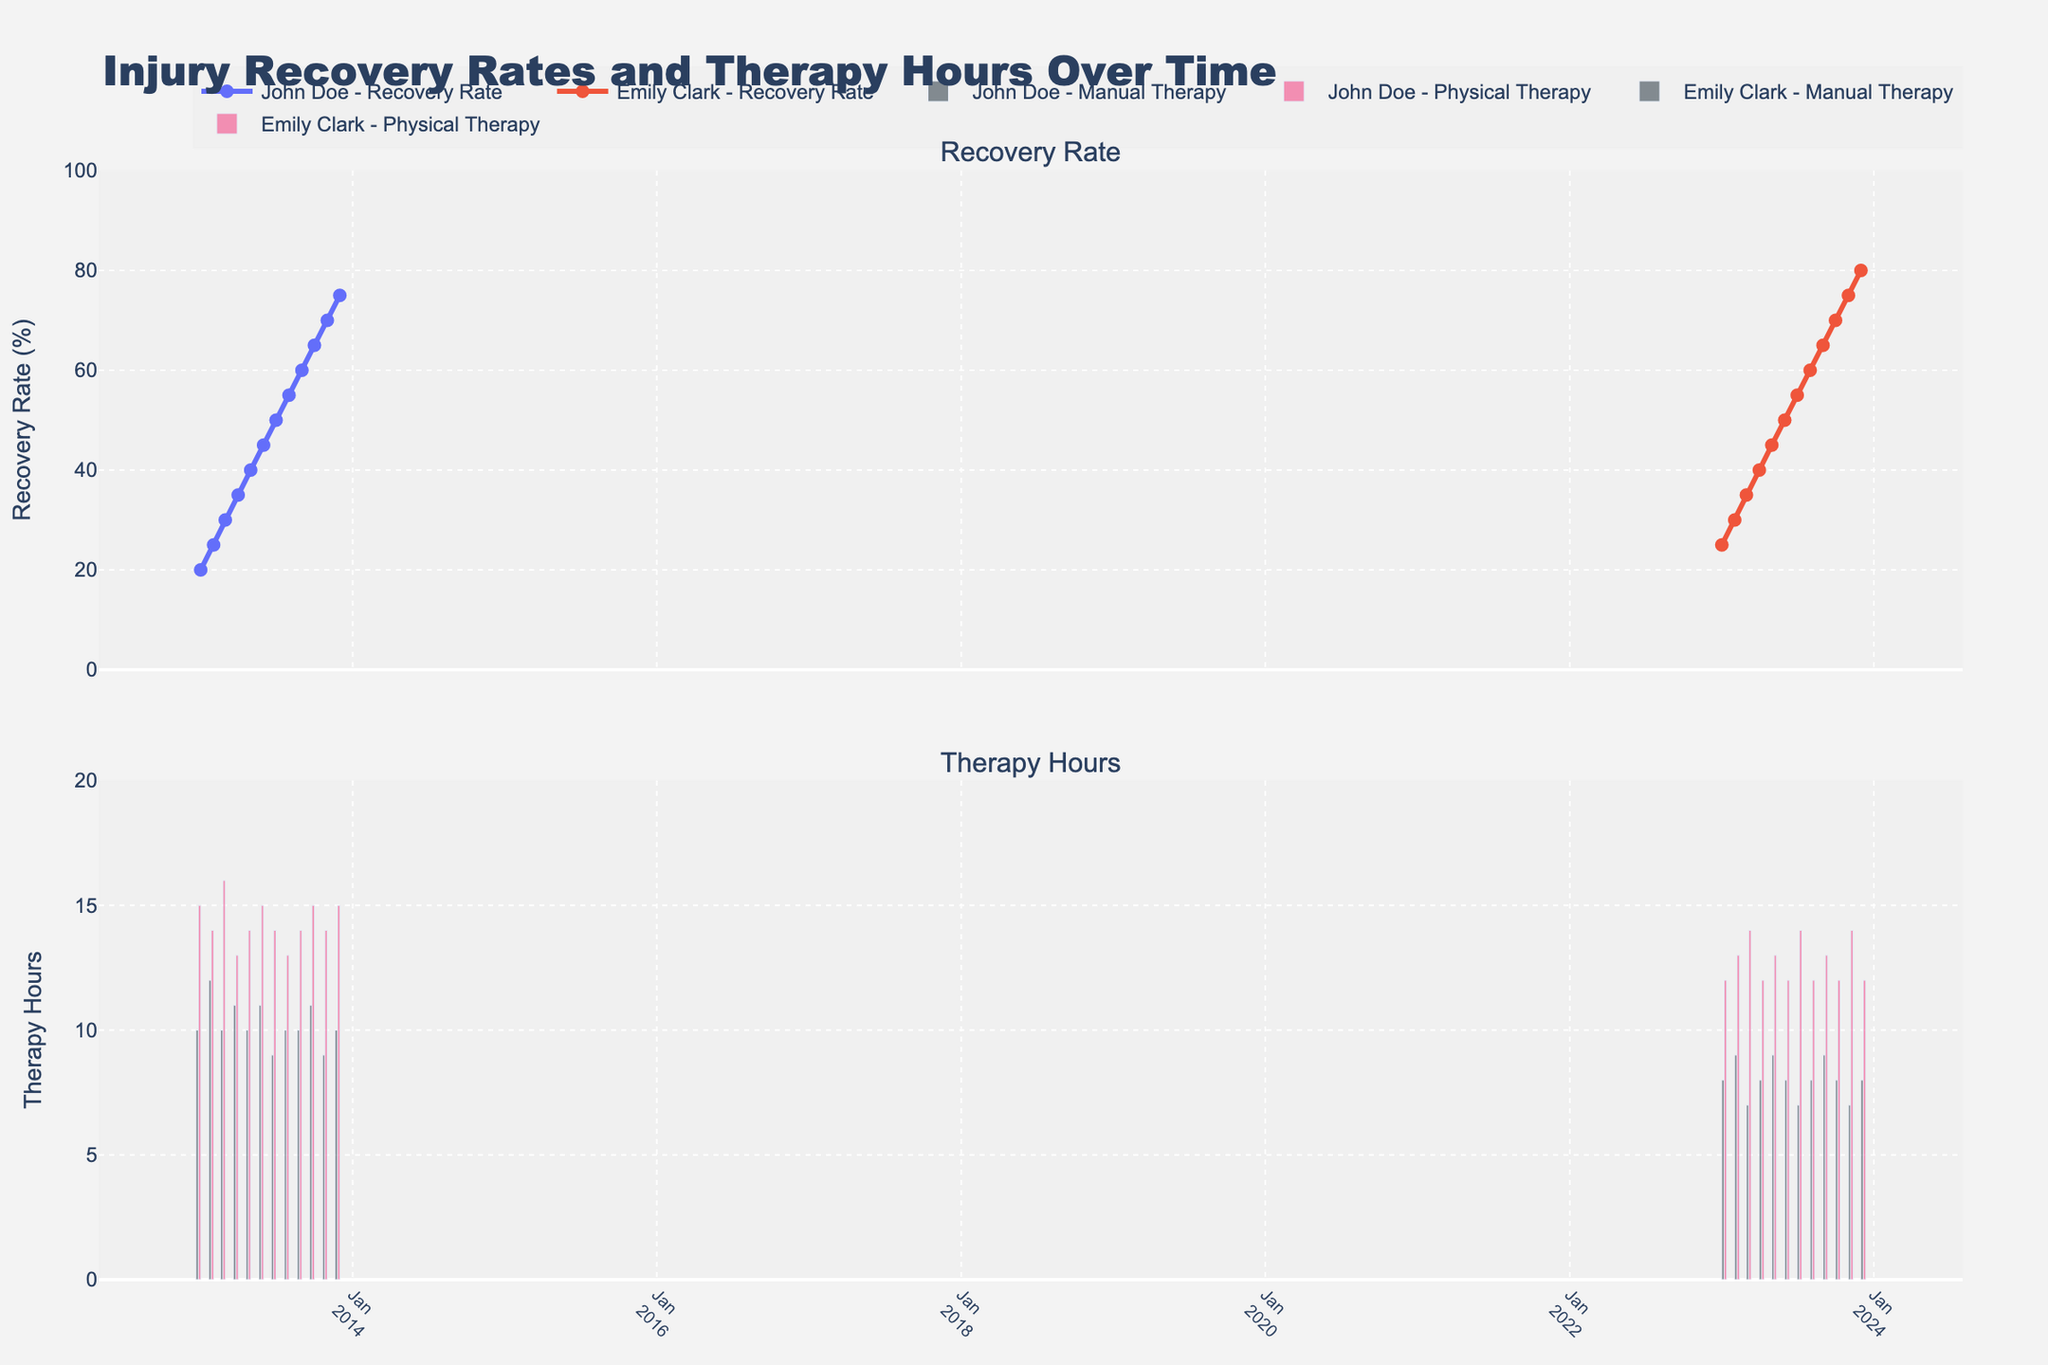What are the titles of the subplots? The titles of the subplots can be found at the top of each subplot. The first subplot's title is "Recovery Rate" and the second subplot's title is "Therapy Hours".
Answer: Recovery Rate, Therapy Hours How did John Doe's recovery rate change from January to December 2013? To determine this, observe the line with markers representing John Doe's recovery rate in the "Recovery Rate" subplot. In January, it is 20%, and it increases steadily each month, reaching 75% by December 2013.
Answer: Increased from 20% to 75% How many manual therapy hours did Emily Clark receive in November 2023? Locate the bar for Emily Clark's manual therapy hours in November 2023 in the "Therapy Hours" subplot. The height of the bar indicates the number of hours, which is 7 hours.
Answer: 7 hours What is the range of recovery rates shown on the y-axis in the "Recovery Rate" subplot? Observe the y-axis of the "Recovery Rate" subplot. The range marked on the axis is from 0% to 100% with intervals of 20%.
Answer: 0% to 100% Which athlete had a greater increase in their recovery rate over the tracked period, John Doe or Emily Clark? To compare, calculate the increase for each athlete. John Doe's recovery rate increased from 20% to 75% (an increase of 55%) from January to December 2013. Emily Clark's recovery rate increased from 25% to 80% (an increase of 55%) from January to December 2023. Both athletes had the same increase.
Answer: Both had an increase of 55% What combination of therapy hours did Emily Clark receive for the highest recorded recovery rate? Find the highest recovery rate for Emily Clark in the "Recovery Rate" subplot, which is 80% in December 2023. Then, check the corresponding bars in the "Therapy Hours" subplot for that month - 8 hours of manual therapy and 12 hours of physical therapy.
Answer: 8 hours manual, 12 hours physical How does the trend in therapy hours differ between John Doe and Emily Clark? Look at the "Therapy Hours" subplot. John Doe's therapy hours show a steady pattern with slight variations month-to-month. For Emily Clark, the hours of manual therapy often alternate while the physical therapy hours are more consistent.
Answer: John - steady, Emily - alternating What's the total number of physical therapy hours received by John Doe in the first half of 2013? Sum the physical therapy hours for John Doe from January to June 2013: 15 + 14 + 16 + 13 + 14 + 15 = 87 hours.
Answer: 87 hours 